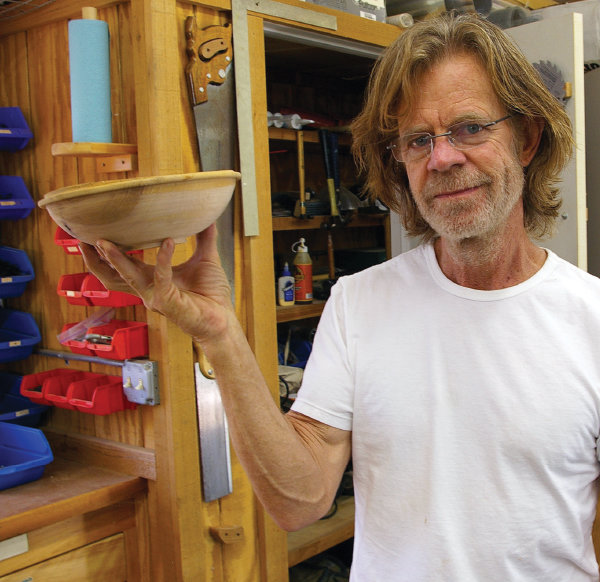Can you describe the mood or atmosphere of the workshop? The workshop exudes a calm and focused atmosphere, with natural light providing a warm and inviting ambiance. The organization of tools and the clear workspace suggest a serious approach to the craft, while the individual's mild expression implies a sense of satisfaction and tranquility in this creative space. 